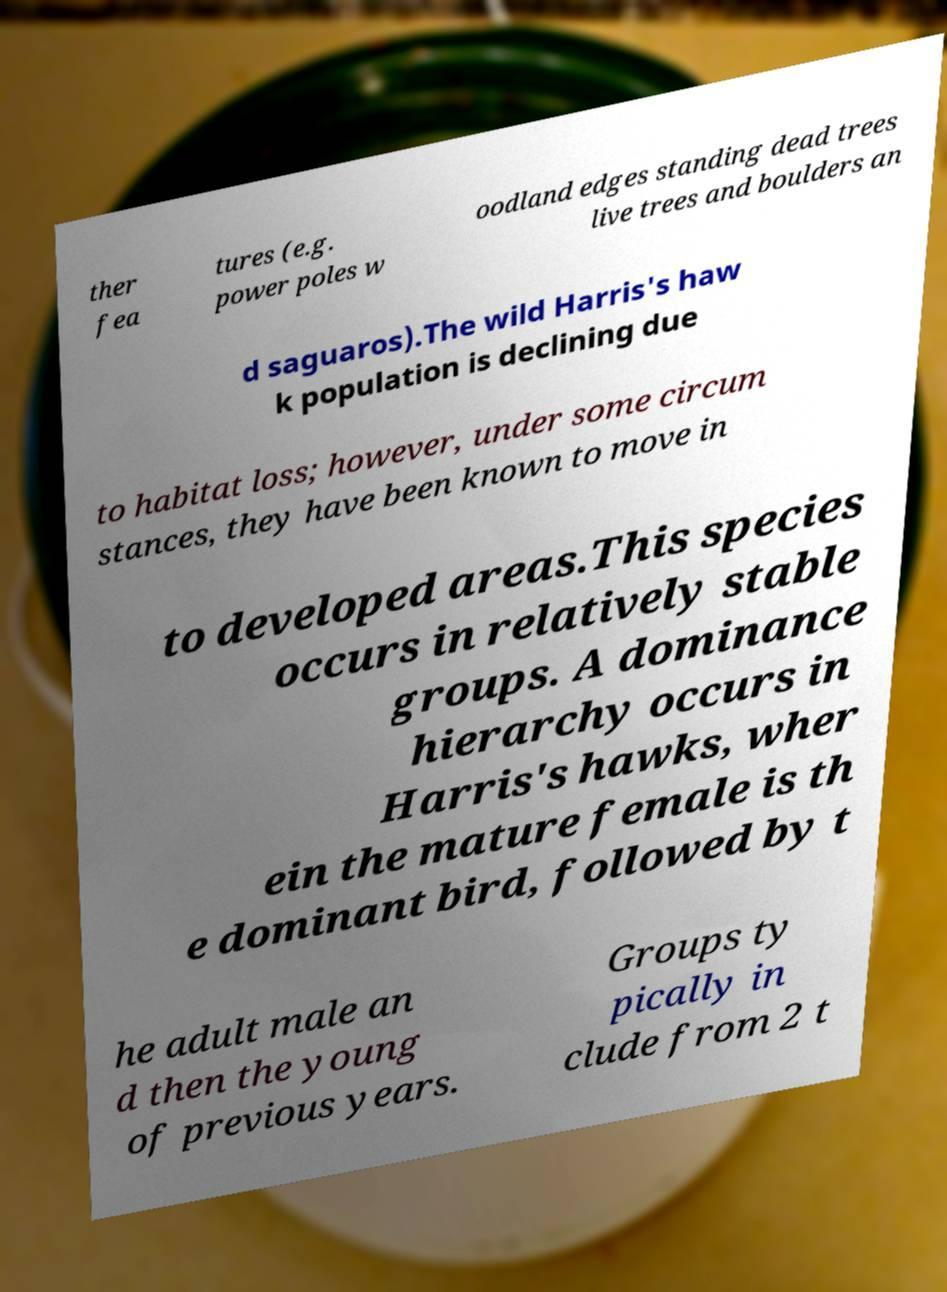Could you extract and type out the text from this image? ther fea tures (e.g. power poles w oodland edges standing dead trees live trees and boulders an d saguaros).The wild Harris's haw k population is declining due to habitat loss; however, under some circum stances, they have been known to move in to developed areas.This species occurs in relatively stable groups. A dominance hierarchy occurs in Harris's hawks, wher ein the mature female is th e dominant bird, followed by t he adult male an d then the young of previous years. Groups ty pically in clude from 2 t 